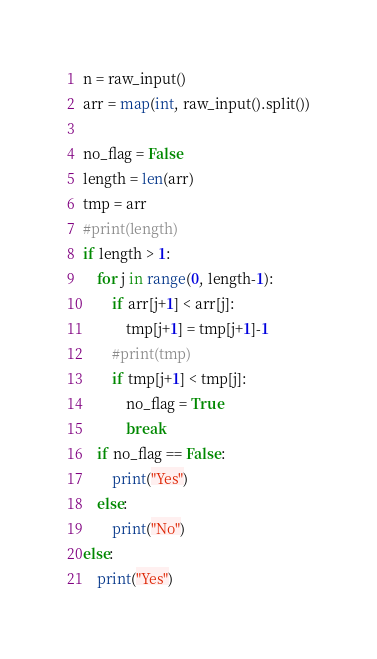Convert code to text. <code><loc_0><loc_0><loc_500><loc_500><_Python_>n = raw_input()
arr = map(int, raw_input().split())

no_flag = False
length = len(arr)
tmp = arr
#print(length)
if length > 1:
    for j in range(0, length-1):
        if arr[j+1] < arr[j]:
            tmp[j+1] = tmp[j+1]-1
        #print(tmp)
        if tmp[j+1] < tmp[j]:
            no_flag = True
            break
    if no_flag == False:
        print("Yes")
    else:
        print("No")
else:
    print("Yes")
</code> 